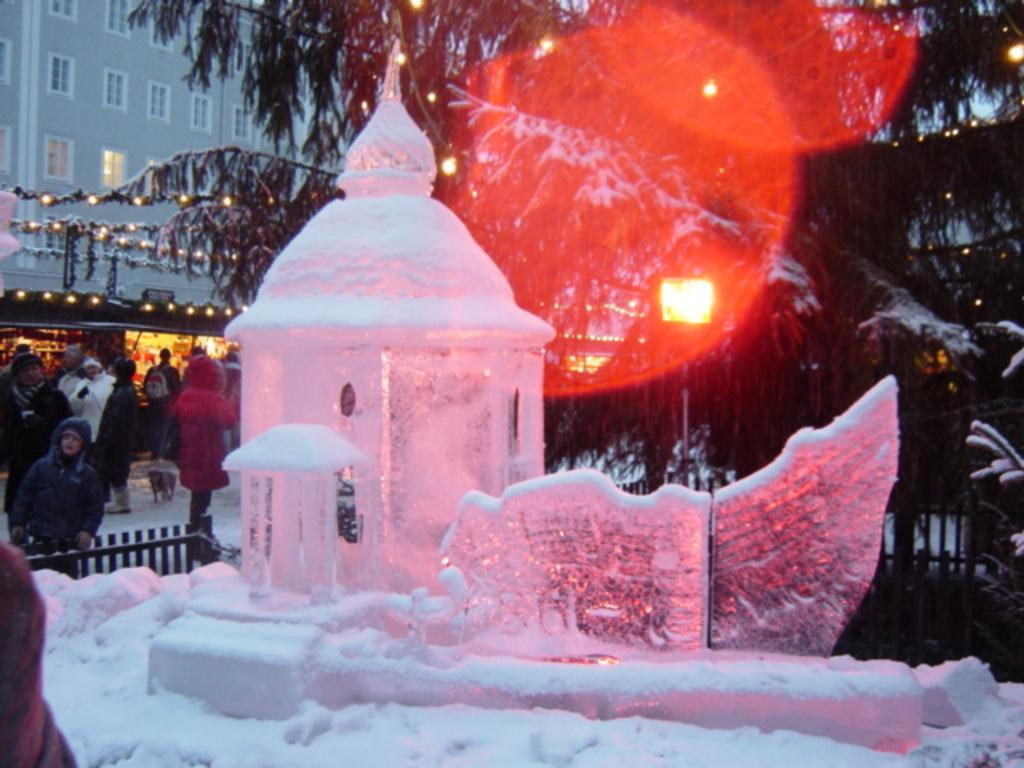What is the main subject of the image? The main subject of the image is an ice sculpture of a building. What can be seen in the background of the image? In the background of the image, there is a fence, trees, at least one building, stalls, lights, and a group of people standing on the snow. Can you describe the describe the setting of the image? The image appears to be set in a wintery environment, with snow on the ground and ice sculptures. What type of addition is being performed by the tank in the image? There is no tank present in the image, so it is not possible to answer that question. 